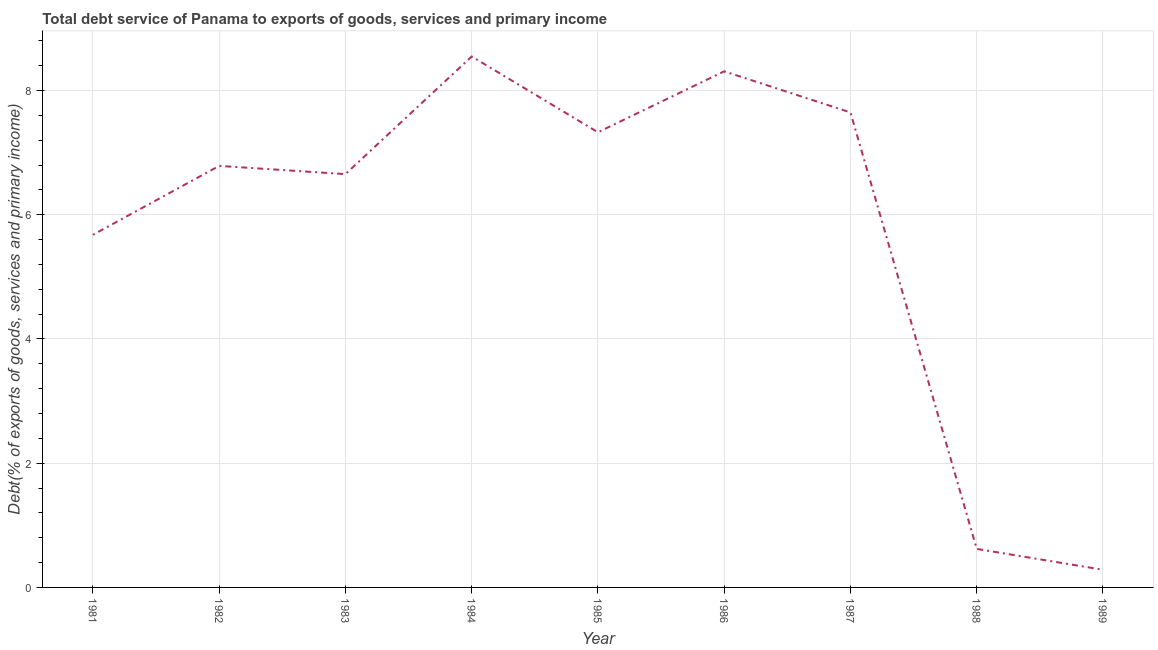What is the total debt service in 1981?
Offer a very short reply. 5.68. Across all years, what is the maximum total debt service?
Your response must be concise. 8.55. Across all years, what is the minimum total debt service?
Provide a short and direct response. 0.28. What is the sum of the total debt service?
Ensure brevity in your answer.  51.85. What is the difference between the total debt service in 1983 and 1988?
Your answer should be very brief. 6.03. What is the average total debt service per year?
Your answer should be very brief. 5.76. What is the median total debt service?
Make the answer very short. 6.79. What is the ratio of the total debt service in 1985 to that in 1988?
Make the answer very short. 11.82. Is the difference between the total debt service in 1981 and 1989 greater than the difference between any two years?
Keep it short and to the point. No. What is the difference between the highest and the second highest total debt service?
Keep it short and to the point. 0.24. What is the difference between the highest and the lowest total debt service?
Keep it short and to the point. 8.26. Does the total debt service monotonically increase over the years?
Your answer should be compact. No. Does the graph contain grids?
Offer a very short reply. Yes. What is the title of the graph?
Ensure brevity in your answer.  Total debt service of Panama to exports of goods, services and primary income. What is the label or title of the Y-axis?
Give a very brief answer. Debt(% of exports of goods, services and primary income). What is the Debt(% of exports of goods, services and primary income) in 1981?
Offer a terse response. 5.68. What is the Debt(% of exports of goods, services and primary income) in 1982?
Provide a short and direct response. 6.79. What is the Debt(% of exports of goods, services and primary income) of 1983?
Your response must be concise. 6.65. What is the Debt(% of exports of goods, services and primary income) of 1984?
Your answer should be very brief. 8.55. What is the Debt(% of exports of goods, services and primary income) of 1985?
Offer a very short reply. 7.33. What is the Debt(% of exports of goods, services and primary income) of 1986?
Ensure brevity in your answer.  8.31. What is the Debt(% of exports of goods, services and primary income) of 1987?
Provide a short and direct response. 7.65. What is the Debt(% of exports of goods, services and primary income) in 1988?
Keep it short and to the point. 0.62. What is the Debt(% of exports of goods, services and primary income) of 1989?
Your answer should be very brief. 0.28. What is the difference between the Debt(% of exports of goods, services and primary income) in 1981 and 1982?
Make the answer very short. -1.11. What is the difference between the Debt(% of exports of goods, services and primary income) in 1981 and 1983?
Give a very brief answer. -0.98. What is the difference between the Debt(% of exports of goods, services and primary income) in 1981 and 1984?
Ensure brevity in your answer.  -2.87. What is the difference between the Debt(% of exports of goods, services and primary income) in 1981 and 1985?
Provide a succinct answer. -1.65. What is the difference between the Debt(% of exports of goods, services and primary income) in 1981 and 1986?
Make the answer very short. -2.63. What is the difference between the Debt(% of exports of goods, services and primary income) in 1981 and 1987?
Give a very brief answer. -1.97. What is the difference between the Debt(% of exports of goods, services and primary income) in 1981 and 1988?
Your answer should be compact. 5.06. What is the difference between the Debt(% of exports of goods, services and primary income) in 1981 and 1989?
Provide a succinct answer. 5.39. What is the difference between the Debt(% of exports of goods, services and primary income) in 1982 and 1983?
Offer a very short reply. 0.13. What is the difference between the Debt(% of exports of goods, services and primary income) in 1982 and 1984?
Your answer should be compact. -1.76. What is the difference between the Debt(% of exports of goods, services and primary income) in 1982 and 1985?
Provide a succinct answer. -0.54. What is the difference between the Debt(% of exports of goods, services and primary income) in 1982 and 1986?
Give a very brief answer. -1.52. What is the difference between the Debt(% of exports of goods, services and primary income) in 1982 and 1987?
Your response must be concise. -0.86. What is the difference between the Debt(% of exports of goods, services and primary income) in 1982 and 1988?
Provide a short and direct response. 6.17. What is the difference between the Debt(% of exports of goods, services and primary income) in 1982 and 1989?
Your answer should be compact. 6.5. What is the difference between the Debt(% of exports of goods, services and primary income) in 1983 and 1984?
Ensure brevity in your answer.  -1.89. What is the difference between the Debt(% of exports of goods, services and primary income) in 1983 and 1985?
Your answer should be very brief. -0.67. What is the difference between the Debt(% of exports of goods, services and primary income) in 1983 and 1986?
Offer a very short reply. -1.65. What is the difference between the Debt(% of exports of goods, services and primary income) in 1983 and 1987?
Offer a very short reply. -0.99. What is the difference between the Debt(% of exports of goods, services and primary income) in 1983 and 1988?
Your response must be concise. 6.03. What is the difference between the Debt(% of exports of goods, services and primary income) in 1983 and 1989?
Make the answer very short. 6.37. What is the difference between the Debt(% of exports of goods, services and primary income) in 1984 and 1985?
Ensure brevity in your answer.  1.22. What is the difference between the Debt(% of exports of goods, services and primary income) in 1984 and 1986?
Your answer should be very brief. 0.24. What is the difference between the Debt(% of exports of goods, services and primary income) in 1984 and 1987?
Your answer should be compact. 0.9. What is the difference between the Debt(% of exports of goods, services and primary income) in 1984 and 1988?
Provide a short and direct response. 7.93. What is the difference between the Debt(% of exports of goods, services and primary income) in 1984 and 1989?
Ensure brevity in your answer.  8.26. What is the difference between the Debt(% of exports of goods, services and primary income) in 1985 and 1986?
Provide a short and direct response. -0.98. What is the difference between the Debt(% of exports of goods, services and primary income) in 1985 and 1987?
Provide a succinct answer. -0.32. What is the difference between the Debt(% of exports of goods, services and primary income) in 1985 and 1988?
Give a very brief answer. 6.71. What is the difference between the Debt(% of exports of goods, services and primary income) in 1985 and 1989?
Your response must be concise. 7.04. What is the difference between the Debt(% of exports of goods, services and primary income) in 1986 and 1987?
Your answer should be compact. 0.66. What is the difference between the Debt(% of exports of goods, services and primary income) in 1986 and 1988?
Offer a very short reply. 7.69. What is the difference between the Debt(% of exports of goods, services and primary income) in 1986 and 1989?
Ensure brevity in your answer.  8.02. What is the difference between the Debt(% of exports of goods, services and primary income) in 1987 and 1988?
Provide a short and direct response. 7.03. What is the difference between the Debt(% of exports of goods, services and primary income) in 1987 and 1989?
Your response must be concise. 7.36. What is the difference between the Debt(% of exports of goods, services and primary income) in 1988 and 1989?
Your answer should be compact. 0.34. What is the ratio of the Debt(% of exports of goods, services and primary income) in 1981 to that in 1982?
Ensure brevity in your answer.  0.84. What is the ratio of the Debt(% of exports of goods, services and primary income) in 1981 to that in 1983?
Give a very brief answer. 0.85. What is the ratio of the Debt(% of exports of goods, services and primary income) in 1981 to that in 1984?
Your answer should be very brief. 0.66. What is the ratio of the Debt(% of exports of goods, services and primary income) in 1981 to that in 1985?
Your answer should be compact. 0.78. What is the ratio of the Debt(% of exports of goods, services and primary income) in 1981 to that in 1986?
Keep it short and to the point. 0.68. What is the ratio of the Debt(% of exports of goods, services and primary income) in 1981 to that in 1987?
Offer a terse response. 0.74. What is the ratio of the Debt(% of exports of goods, services and primary income) in 1981 to that in 1988?
Make the answer very short. 9.15. What is the ratio of the Debt(% of exports of goods, services and primary income) in 1981 to that in 1989?
Provide a succinct answer. 19.96. What is the ratio of the Debt(% of exports of goods, services and primary income) in 1982 to that in 1984?
Ensure brevity in your answer.  0.79. What is the ratio of the Debt(% of exports of goods, services and primary income) in 1982 to that in 1985?
Offer a very short reply. 0.93. What is the ratio of the Debt(% of exports of goods, services and primary income) in 1982 to that in 1986?
Ensure brevity in your answer.  0.82. What is the ratio of the Debt(% of exports of goods, services and primary income) in 1982 to that in 1987?
Offer a terse response. 0.89. What is the ratio of the Debt(% of exports of goods, services and primary income) in 1982 to that in 1988?
Make the answer very short. 10.95. What is the ratio of the Debt(% of exports of goods, services and primary income) in 1982 to that in 1989?
Offer a very short reply. 23.86. What is the ratio of the Debt(% of exports of goods, services and primary income) in 1983 to that in 1984?
Provide a succinct answer. 0.78. What is the ratio of the Debt(% of exports of goods, services and primary income) in 1983 to that in 1985?
Give a very brief answer. 0.91. What is the ratio of the Debt(% of exports of goods, services and primary income) in 1983 to that in 1986?
Your response must be concise. 0.8. What is the ratio of the Debt(% of exports of goods, services and primary income) in 1983 to that in 1987?
Give a very brief answer. 0.87. What is the ratio of the Debt(% of exports of goods, services and primary income) in 1983 to that in 1988?
Your answer should be compact. 10.73. What is the ratio of the Debt(% of exports of goods, services and primary income) in 1983 to that in 1989?
Offer a terse response. 23.39. What is the ratio of the Debt(% of exports of goods, services and primary income) in 1984 to that in 1985?
Make the answer very short. 1.17. What is the ratio of the Debt(% of exports of goods, services and primary income) in 1984 to that in 1986?
Keep it short and to the point. 1.03. What is the ratio of the Debt(% of exports of goods, services and primary income) in 1984 to that in 1987?
Your answer should be very brief. 1.12. What is the ratio of the Debt(% of exports of goods, services and primary income) in 1984 to that in 1988?
Provide a short and direct response. 13.79. What is the ratio of the Debt(% of exports of goods, services and primary income) in 1984 to that in 1989?
Make the answer very short. 30.05. What is the ratio of the Debt(% of exports of goods, services and primary income) in 1985 to that in 1986?
Provide a succinct answer. 0.88. What is the ratio of the Debt(% of exports of goods, services and primary income) in 1985 to that in 1987?
Provide a succinct answer. 0.96. What is the ratio of the Debt(% of exports of goods, services and primary income) in 1985 to that in 1988?
Offer a very short reply. 11.82. What is the ratio of the Debt(% of exports of goods, services and primary income) in 1985 to that in 1989?
Give a very brief answer. 25.76. What is the ratio of the Debt(% of exports of goods, services and primary income) in 1986 to that in 1987?
Your answer should be very brief. 1.09. What is the ratio of the Debt(% of exports of goods, services and primary income) in 1986 to that in 1988?
Offer a terse response. 13.4. What is the ratio of the Debt(% of exports of goods, services and primary income) in 1986 to that in 1989?
Offer a terse response. 29.21. What is the ratio of the Debt(% of exports of goods, services and primary income) in 1987 to that in 1988?
Offer a terse response. 12.33. What is the ratio of the Debt(% of exports of goods, services and primary income) in 1987 to that in 1989?
Keep it short and to the point. 26.88. What is the ratio of the Debt(% of exports of goods, services and primary income) in 1988 to that in 1989?
Offer a very short reply. 2.18. 